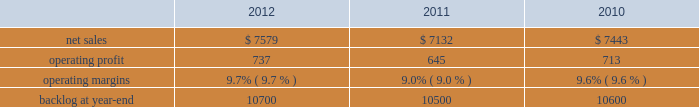2011 compared to 2010 mfc 2019s net sales for 2011 increased $ 533 million , or 8% ( 8 % ) , compared to 2010 .
The increase was attributable to higher volume of about $ 420 million on air and missile defense programs ( primarily pac-3 and thaad ) ; and about $ 245 million from fire control systems programs primarily related to the sof clss program , which began late in the third quarter of 2010 .
Partially offsetting these increases were lower net sales due to decreased volume of approximately $ 75 million primarily from various services programs and approximately $ 20 million from tactical missile programs ( primarily mlrs and jassm ) .
Mfc 2019s operating profit for 2011 increased $ 96 million , or 10% ( 10 % ) , compared to 2010 .
The increase was attributable to higher operating profit of about $ 60 million for air and missile defense programs ( primarily pac-3 and thaad ) as a result of increased volume and retirement of risks ; and approximately $ 25 million for various services programs .
Adjustments not related to volume , including net profit rate adjustments described above , were approximately $ 35 million higher in 2011 compared to 2010 .
Backlog backlog increased in 2012 compared to 2011 mainly due to increased orders and lower sales on fire control systems programs ( primarily lantirn ae and sniper ae ) and on various services programs , partially offset by lower orders and higher sales volume on tactical missiles programs .
Backlog increased in 2011 compared to 2010 primarily due to increased orders on air and missile defense programs ( primarily thaad ) .
Trends we expect mfc 2019s net sales for 2013 will be comparable with 2012 .
We expect low double digit percentage growth in air and missile defense programs , offset by an expected decline in volume on logistics services programs .
Operating profit and margin are expected to be comparable with 2012 results .
Mission systems and training our mst business segment provides surface ship and submarine combat systems ; sea and land-based missile defense systems ; radar systems ; mission systems and sensors for rotary and fixed-wing aircraft ; littoral combat ships ; simulation and training services ; unmanned technologies and platforms ; ship systems integration ; and military and commercial training systems .
Mst 2019s major programs include aegis , mk-41 vertical launching system ( vls ) , tpq-53 radar system , mh-60 , lcs , and ptds .
Mst 2019s operating results included the following ( in millions ) : .
2012 compared to 2011 mst 2019s net sales for 2012 increased $ 447 million , or 6% ( 6 % ) , compared to 2011 .
The increase in net sales for 2012 was attributable to higher volume and risk retirements of approximately $ 395 million from ship and aviation system programs ( primarily ptds ; lcs ; vls ; and mh-60 ) ; about $ 115 million for training and logistics solutions programs primarily due to net sales from sim industries , which was acquired in the fourth quarter of 2011 ; and approximately $ 30 million as a result of increased volume on integrated warfare systems and sensors programs ( primarily aegis ) .
Partially offsetting the increases were lower net sales of approximately $ 70 million from undersea systems programs due to lower volume on an international combat system program and towed array systems ; and about $ 25 million due to lower volume on various other programs .
Mst 2019s operating profit for 2012 increased $ 92 million , or 14% ( 14 % ) , compared to 2011 .
The increase was attributable to higher operating profit of approximately $ 175 million from ship and aviation system programs , which reflects higher volume and risk retirements on certain programs ( primarily vls ; ptds ; mh-60 ; and lcs ) and reserves of about $ 55 million for contract cost matters on ship and aviation system programs recorded in the fourth quarter of 2011 ( including the terminated presidential helicopter program ) .
Partially offsetting the increase was lower operating profit of approximately $ 40 million from undersea systems programs due to reduced profit booking rates on certain programs and lower volume on an international combat system program and towed array systems ; and about $ 40 million due to lower volume on various other programs .
Adjustments not related to volume , including net profit booking rate adjustments and other matters described above , were approximately $ 150 million higher for 2012 compared to 2011. .
What was the ratio of the mst 2019 change in net sales compared to msf from 2010 to 2011? 
Computations: ((7132 - 7443) / 533)
Answer: -0.58349. 